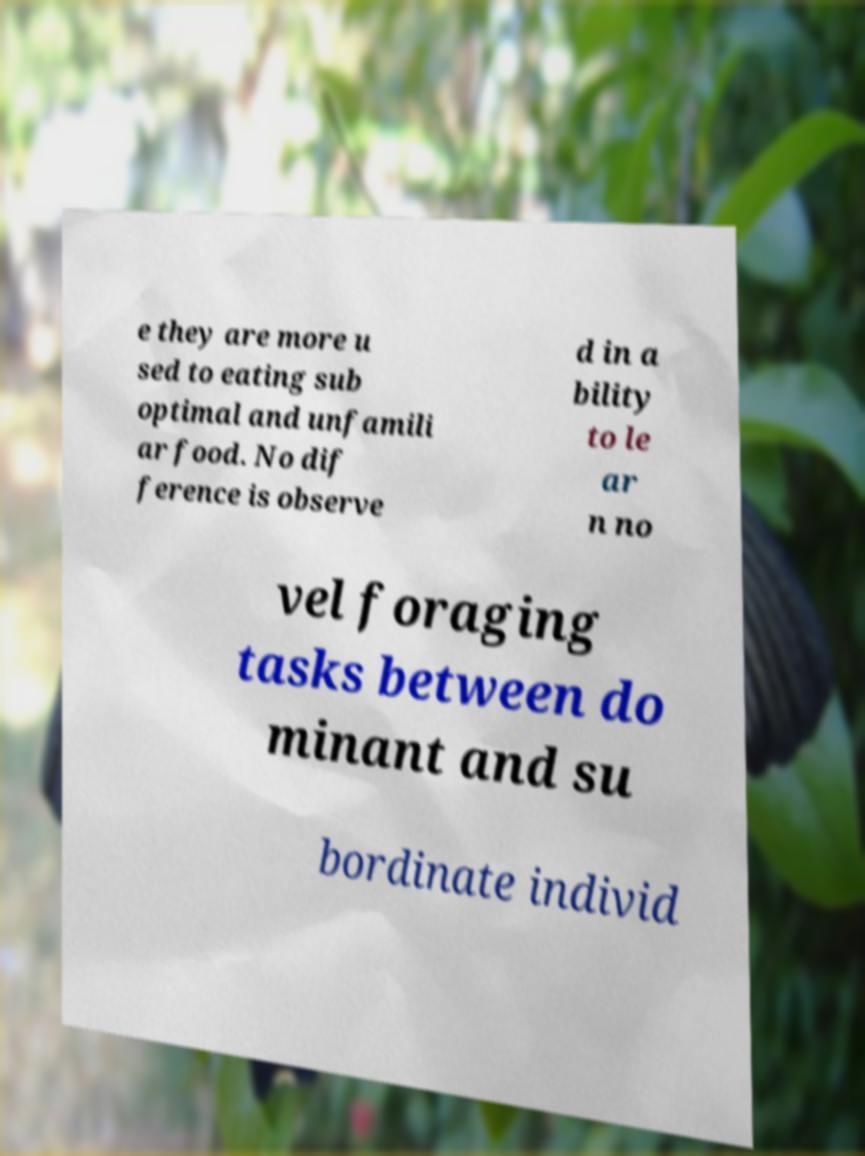Can you read and provide the text displayed in the image?This photo seems to have some interesting text. Can you extract and type it out for me? e they are more u sed to eating sub optimal and unfamili ar food. No dif ference is observe d in a bility to le ar n no vel foraging tasks between do minant and su bordinate individ 